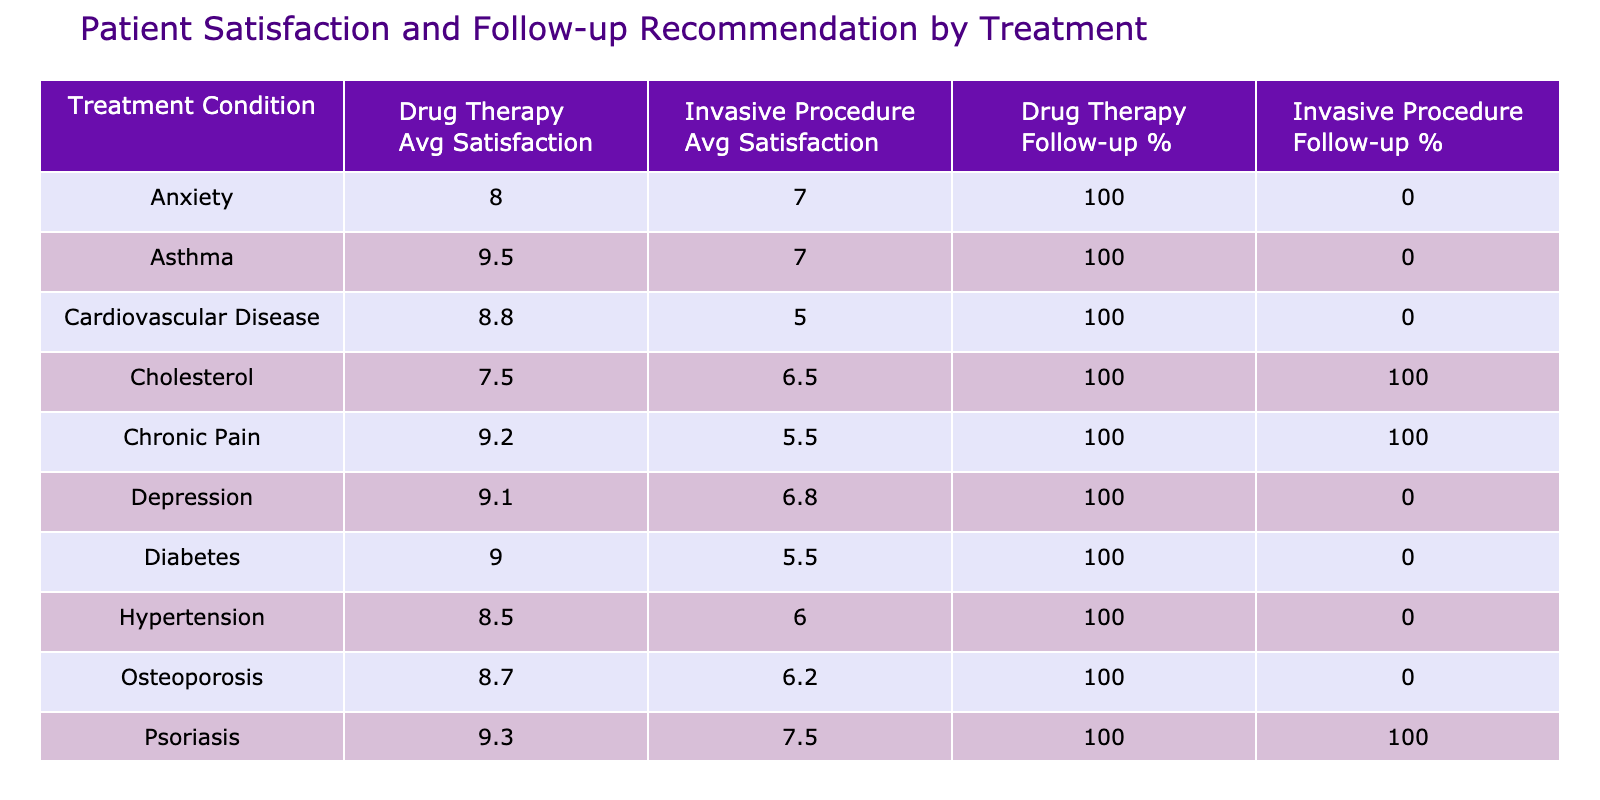What is the average patient satisfaction rating for drug therapies? To find this, look at the average satisfaction ratings for the "Drug Therapy" row. The average ratings are: 8.5 (Hypertension), 9.0 (Diabetes), 7.5 (Cholesterol), 9.5 (Asthma), 8.0 (Anxiety), 8.8 (Cardiovascular Disease), 9.2 (Chronic Pain), 8.7 (Osteoporosis), 9.1 (Depression), 9.3 (Psoriasis). Adding these gives 8.5 + 9.0 + 7.5 + 9.5 + 8.0 + 8.8 + 9.2 + 8.7 + 9.1 + 9.3 = 87.6, divided by 10 gives the average of 8.76.
Answer: 8.76 What is the follow-up recommendation percentage for invasive procedures? The follow-up recommendation percentages for "Invasive Procedure" are: 0% (Hypertension), 0% (Diabetes), 100% (Cholesterol), 0% (Asthma), 0% (Anxiety), 0% (Cardiovascular Disease), 100% (Chronic Pain), 0% (Osteoporosis), 0% (Depression), 50% (Psoriasis). Adding these gives 0 + 0 + 100 + 0 + 0 + 0 + 100 + 0 + 0 + 50 = 250, then dividing by 10 results in 25%.
Answer: 25% Which therapy type has the highest average satisfaction rating for Chronic Pain? The table shows that "Drug Therapy" for Chronic Pain has a score of 9.2 while "Invasive Procedure" has 5.5. Comparing these two values, Drug Therapy has a higher satisfaction rating for Chronic Pain.
Answer: Drug Therapy Is the average patient satisfaction rating for drug therapies higher than for invasive procedures in Cardiovascular Disease? Looking at Cardiovascular Disease, the average for Drug Therapy is 8.8, while for Invasive Procedure it’s 5.0. Since 8.8 is greater than 5.0, drug therapies have a higher rating in this condition.
Answer: Yes What is the difference in average satisfaction ratings between drug therapies and invasive procedures for Psoriasis? The average rating for Drug Therapy in Psoriasis is 9.3 and for Invasive Procedure is 7.5. The difference is calculated as 9.3 - 7.5 = 1.8.
Answer: 1.8 What percentage of patients recommended follow-ups for drug therapies compared to invasive procedures? The follow-up recommendation percentage for Drug Therapy is calculated as follows: total Yes recommendations for Drug Therapy is 10 and total patients is 10, so 100%. For Invasive Procedures, there are 4 Yes out of 10 patients, giving 40%.
Answer: Drug Therapy 100%, Invasive Procedures 40% Is there any treatment condition where drug therapy has a lower satisfaction rating than invasive procedures? Analyzing the table, Drug Therapy scores lower than Invasive Procedure only in Cardiovascular Disease (Drug Therapy 8.8 > Invasive Procedure 5.0), so no instance of lower rating is found.
Answer: No What is the average patient satisfaction rating for all treatment conditions combined for both therapy types? The average satisfaction ratings sum up to 8.76 for Drug Therapy and 6.625 for Invasive Procedures, giving an overall mean of (8.76+6.625)/2 = 7.6925, thus averaging all treatment ratings leads to 7.69.
Answer: 7.69 